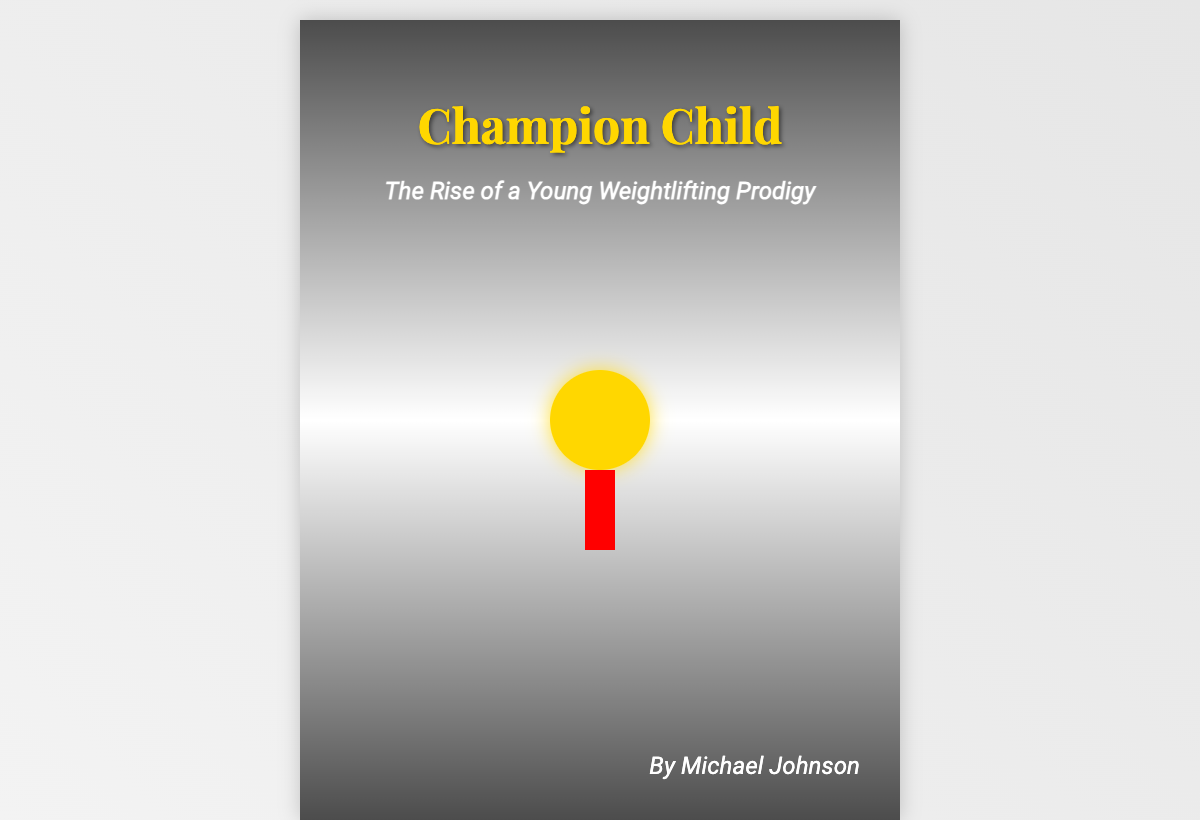What is the title of the book? The title is prominently displayed at the top of the cover, showcasing the main subject of the book.
Answer: Champion Child Who is the author of the book? The author's name is located in the bottom section of the cover, indicating who wrote the book.
Answer: Michael Johnson What is the subtitle of the book? The subtitle complements the title, providing more context about the content of the book.
Answer: The Rise of a Young Weightlifting Prodigy What color is the medal displayed on the cover? The color of the medal is visually represented and stands out as a symbol of achievement.
Answer: Gold What does the young athlete in the cover image hold? The image shows the young athlete with a specific object that signifies victory and success.
Answer: A medal What emotion is the father displaying on the cover? The father's expression in the background indicates a feeling related to the young athlete's achievement.
Answer: Pride In what setting is the young athlete positioned in the cover image? The cover image features the young athlete in a specific scenario that illustrates the theme of competition.
Answer: Podium What is the overall theme of the book as suggested by the cover? The elements in the cover suggest a focus on the journey and achievement in a specific sport.
Answer: Weightlifting What visual effect is applied to the background image? The background image has a specific alteration to enhance the cover's visual appeal.
Answer: Brightness filter 